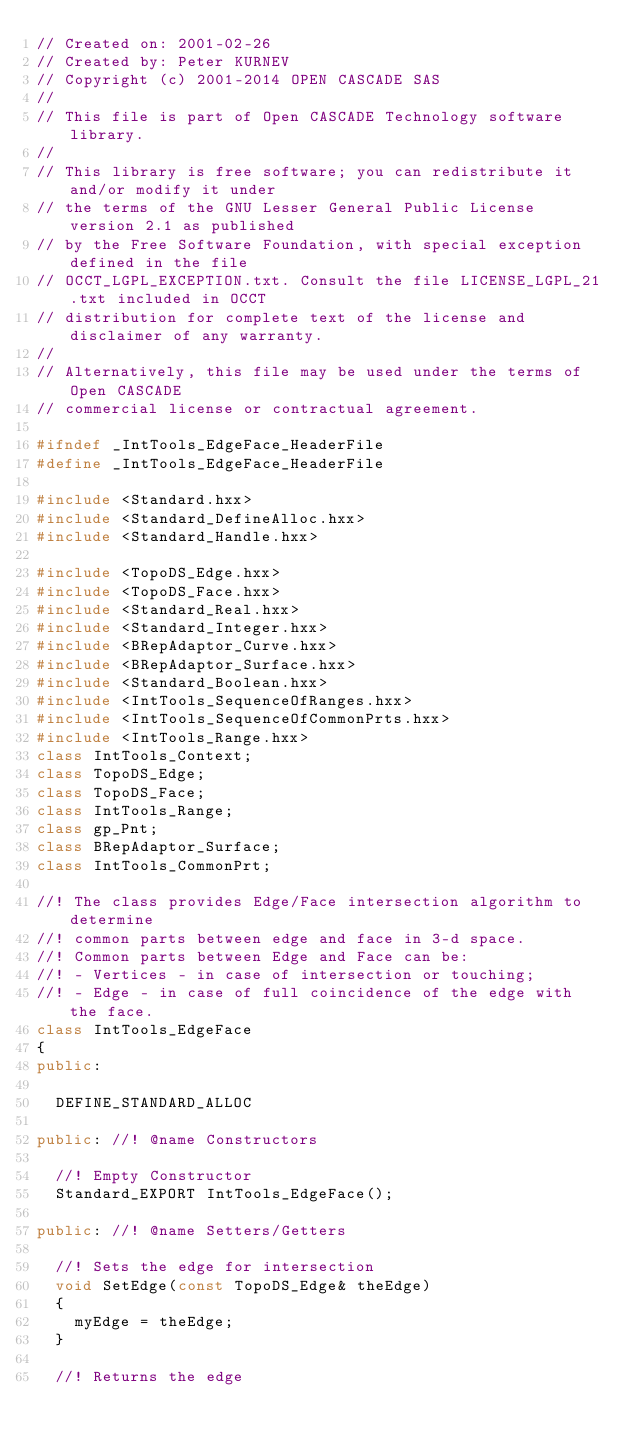Convert code to text. <code><loc_0><loc_0><loc_500><loc_500><_C++_>// Created on: 2001-02-26
// Created by: Peter KURNEV
// Copyright (c) 2001-2014 OPEN CASCADE SAS
//
// This file is part of Open CASCADE Technology software library.
//
// This library is free software; you can redistribute it and/or modify it under
// the terms of the GNU Lesser General Public License version 2.1 as published
// by the Free Software Foundation, with special exception defined in the file
// OCCT_LGPL_EXCEPTION.txt. Consult the file LICENSE_LGPL_21.txt included in OCCT
// distribution for complete text of the license and disclaimer of any warranty.
//
// Alternatively, this file may be used under the terms of Open CASCADE
// commercial license or contractual agreement.

#ifndef _IntTools_EdgeFace_HeaderFile
#define _IntTools_EdgeFace_HeaderFile

#include <Standard.hxx>
#include <Standard_DefineAlloc.hxx>
#include <Standard_Handle.hxx>

#include <TopoDS_Edge.hxx>
#include <TopoDS_Face.hxx>
#include <Standard_Real.hxx>
#include <Standard_Integer.hxx>
#include <BRepAdaptor_Curve.hxx>
#include <BRepAdaptor_Surface.hxx>
#include <Standard_Boolean.hxx>
#include <IntTools_SequenceOfRanges.hxx>
#include <IntTools_SequenceOfCommonPrts.hxx>
#include <IntTools_Range.hxx>
class IntTools_Context;
class TopoDS_Edge;
class TopoDS_Face;
class IntTools_Range;
class gp_Pnt;
class BRepAdaptor_Surface;
class IntTools_CommonPrt;

//! The class provides Edge/Face intersection algorithm to determine
//! common parts between edge and face in 3-d space.
//! Common parts between Edge and Face can be:
//! - Vertices - in case of intersection or touching;
//! - Edge - in case of full coincidence of the edge with the face.
class IntTools_EdgeFace 
{
public:

  DEFINE_STANDARD_ALLOC

public: //! @name Constructors

  //! Empty Constructor
  Standard_EXPORT IntTools_EdgeFace();

public: //! @name Setters/Getters

  //! Sets the edge for intersection
  void SetEdge(const TopoDS_Edge& theEdge)
  {
    myEdge = theEdge;
  }

  //! Returns the edge</code> 